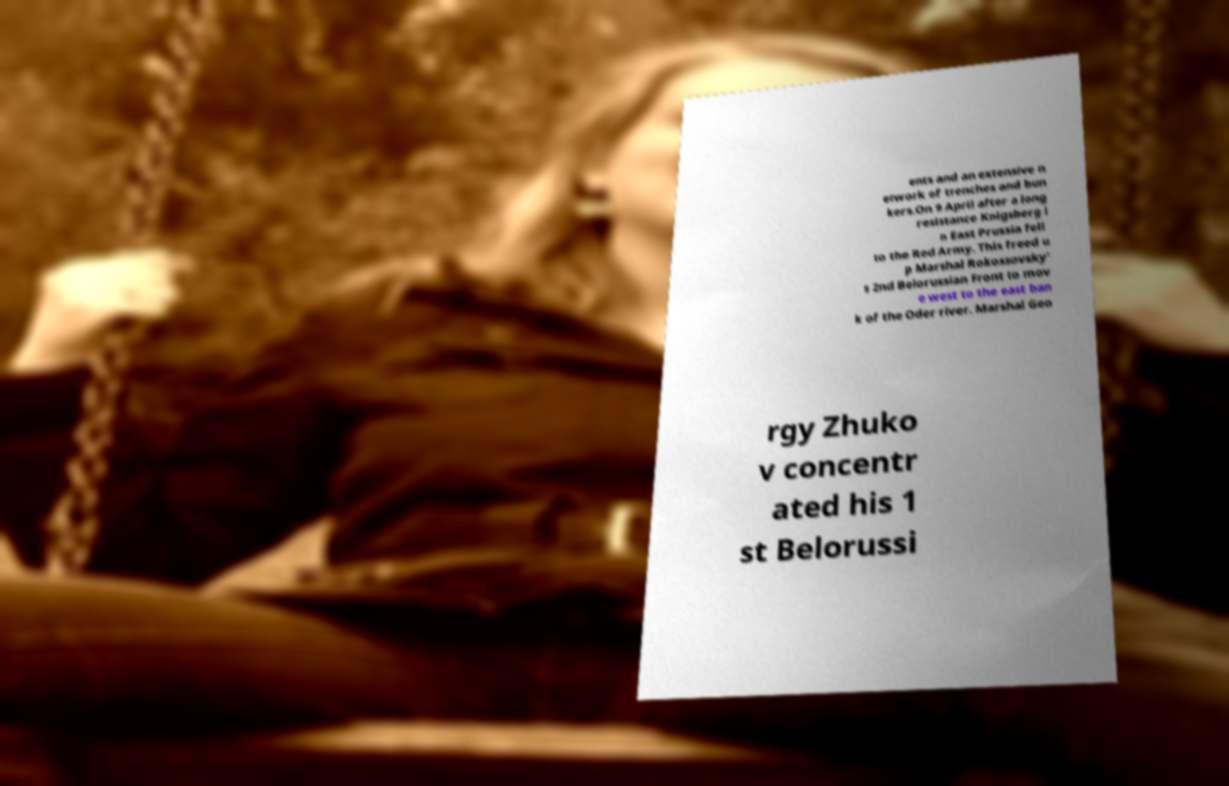I need the written content from this picture converted into text. Can you do that? ents and an extensive n etwork of trenches and bun kers.On 9 April after a long resistance Knigsberg i n East Prussia fell to the Red Army. This freed u p Marshal Rokossovsky' s 2nd Belorussian Front to mov e west to the east ban k of the Oder river. Marshal Geo rgy Zhuko v concentr ated his 1 st Belorussi 